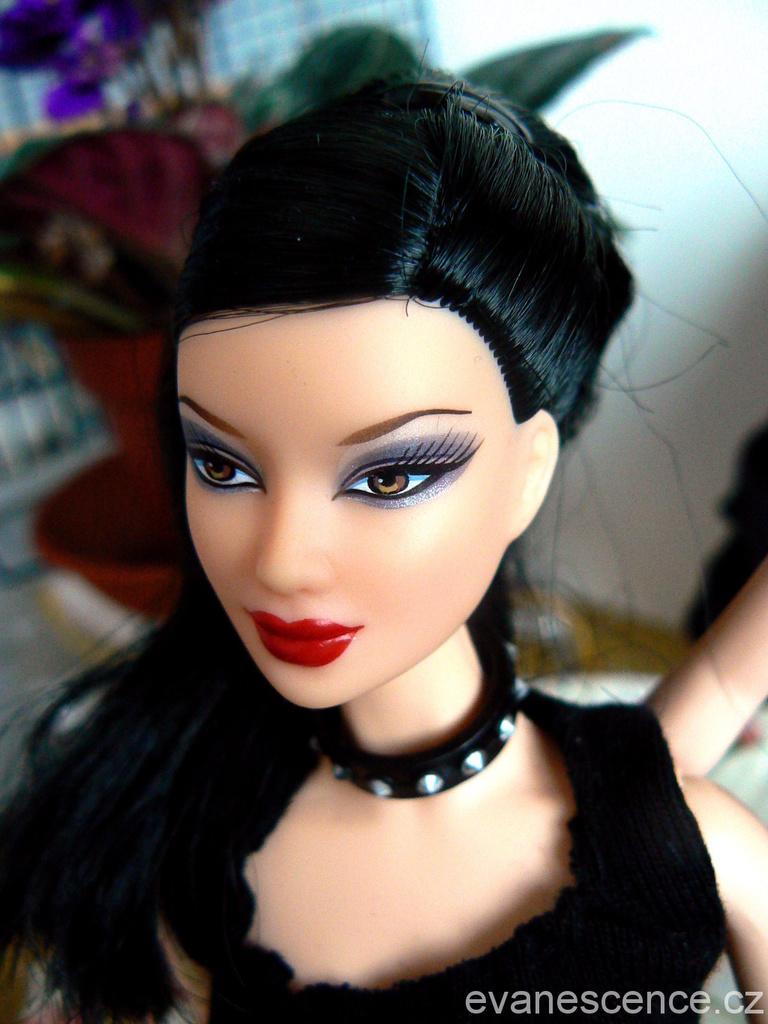Please provide a concise description of this image. In this image I can see a doll, I can see this doll is wearing black dress and black colour belt over here. I can also see watermark over here and I can see this image is little bit blurry from background. 